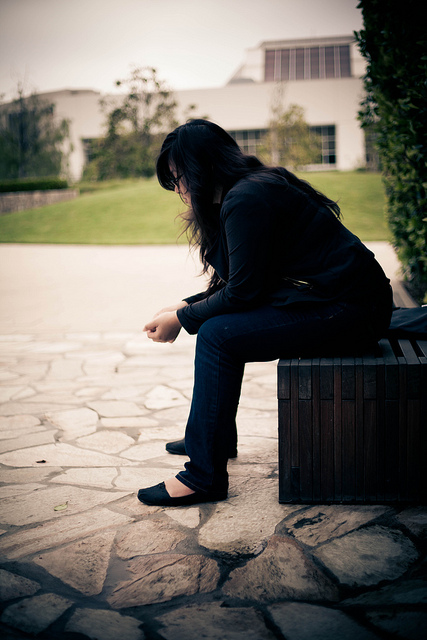<image>Is the woman waiting for someone? I don't know if the woman is waiting for someone. It could be both yes or no. Is the woman waiting for someone? I don't know if the woman is waiting for someone. It could be both yes or no. 